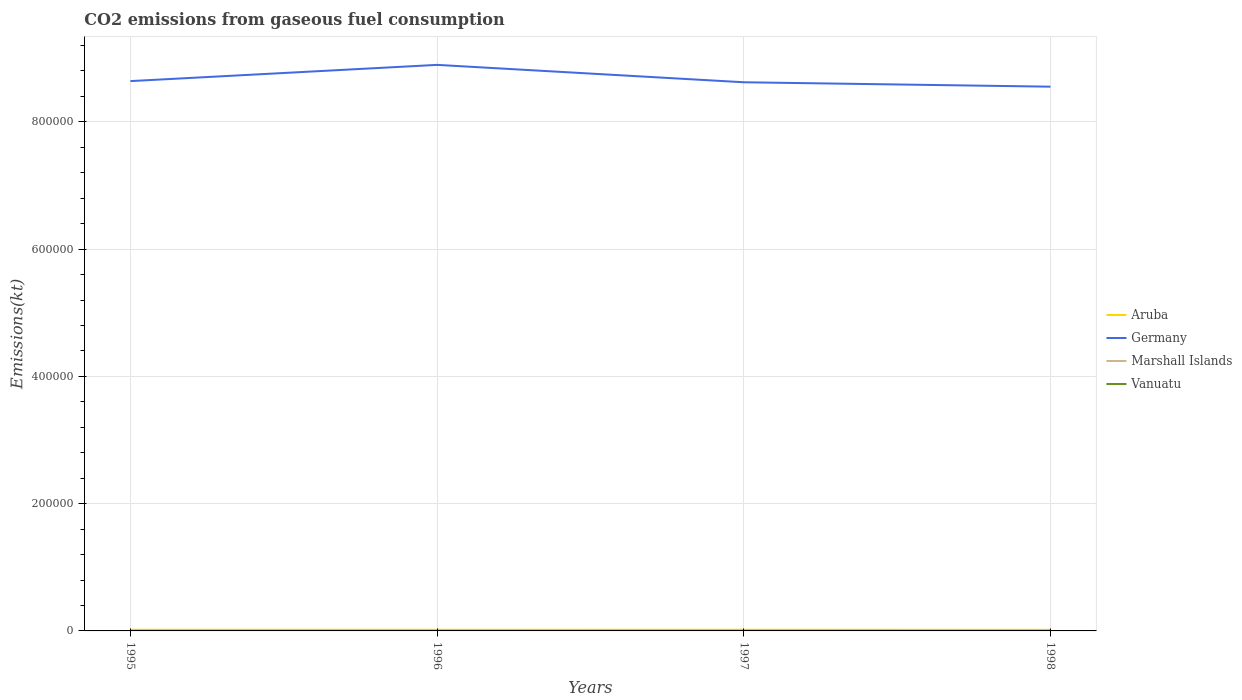Across all years, what is the maximum amount of CO2 emitted in Vanuatu?
Make the answer very short. 66.01. In which year was the amount of CO2 emitted in Marshall Islands maximum?
Your answer should be compact. 1995. What is the total amount of CO2 emitted in Aruba in the graph?
Your response must be concise. -36.67. What is the difference between the highest and the second highest amount of CO2 emitted in Aruba?
Offer a very short reply. 124.68. What is the difference between the highest and the lowest amount of CO2 emitted in Germany?
Your response must be concise. 1. Is the amount of CO2 emitted in Germany strictly greater than the amount of CO2 emitted in Vanuatu over the years?
Your answer should be compact. No. How many lines are there?
Ensure brevity in your answer.  4. Are the values on the major ticks of Y-axis written in scientific E-notation?
Your answer should be very brief. No. Does the graph contain any zero values?
Your response must be concise. No. Does the graph contain grids?
Provide a short and direct response. Yes. Where does the legend appear in the graph?
Offer a terse response. Center right. How many legend labels are there?
Ensure brevity in your answer.  4. How are the legend labels stacked?
Make the answer very short. Vertical. What is the title of the graph?
Keep it short and to the point. CO2 emissions from gaseous fuel consumption. Does "Rwanda" appear as one of the legend labels in the graph?
Give a very brief answer. No. What is the label or title of the Y-axis?
Make the answer very short. Emissions(kt). What is the Emissions(kt) in Aruba in 1995?
Ensure brevity in your answer.  1782.16. What is the Emissions(kt) in Germany in 1995?
Your response must be concise. 8.64e+05. What is the Emissions(kt) of Marshall Islands in 1995?
Provide a succinct answer. 66.01. What is the Emissions(kt) in Vanuatu in 1995?
Your answer should be compact. 66.01. What is the Emissions(kt) in Aruba in 1996?
Your answer should be compact. 1800.5. What is the Emissions(kt) in Germany in 1996?
Make the answer very short. 8.90e+05. What is the Emissions(kt) in Marshall Islands in 1996?
Your answer should be compact. 66.01. What is the Emissions(kt) in Vanuatu in 1996?
Provide a succinct answer. 84.34. What is the Emissions(kt) in Aruba in 1997?
Offer a terse response. 1837.17. What is the Emissions(kt) of Germany in 1997?
Offer a very short reply. 8.62e+05. What is the Emissions(kt) in Marshall Islands in 1997?
Provide a short and direct response. 66.01. What is the Emissions(kt) of Vanuatu in 1997?
Make the answer very short. 88.01. What is the Emissions(kt) of Aruba in 1998?
Give a very brief answer. 1712.49. What is the Emissions(kt) in Germany in 1998?
Your response must be concise. 8.55e+05. What is the Emissions(kt) of Marshall Islands in 1998?
Your answer should be compact. 69.67. What is the Emissions(kt) in Vanuatu in 1998?
Offer a very short reply. 84.34. Across all years, what is the maximum Emissions(kt) of Aruba?
Provide a short and direct response. 1837.17. Across all years, what is the maximum Emissions(kt) in Germany?
Make the answer very short. 8.90e+05. Across all years, what is the maximum Emissions(kt) in Marshall Islands?
Your answer should be very brief. 69.67. Across all years, what is the maximum Emissions(kt) of Vanuatu?
Keep it short and to the point. 88.01. Across all years, what is the minimum Emissions(kt) in Aruba?
Provide a short and direct response. 1712.49. Across all years, what is the minimum Emissions(kt) in Germany?
Your answer should be very brief. 8.55e+05. Across all years, what is the minimum Emissions(kt) in Marshall Islands?
Provide a short and direct response. 66.01. Across all years, what is the minimum Emissions(kt) in Vanuatu?
Your answer should be very brief. 66.01. What is the total Emissions(kt) in Aruba in the graph?
Give a very brief answer. 7132.31. What is the total Emissions(kt) in Germany in the graph?
Your response must be concise. 3.47e+06. What is the total Emissions(kt) in Marshall Islands in the graph?
Your answer should be very brief. 267.69. What is the total Emissions(kt) of Vanuatu in the graph?
Keep it short and to the point. 322.7. What is the difference between the Emissions(kt) in Aruba in 1995 and that in 1996?
Your answer should be very brief. -18.34. What is the difference between the Emissions(kt) of Germany in 1995 and that in 1996?
Provide a short and direct response. -2.55e+04. What is the difference between the Emissions(kt) of Marshall Islands in 1995 and that in 1996?
Your answer should be very brief. 0. What is the difference between the Emissions(kt) in Vanuatu in 1995 and that in 1996?
Your answer should be very brief. -18.34. What is the difference between the Emissions(kt) of Aruba in 1995 and that in 1997?
Offer a very short reply. -55.01. What is the difference between the Emissions(kt) of Germany in 1995 and that in 1997?
Ensure brevity in your answer.  1833.5. What is the difference between the Emissions(kt) in Marshall Islands in 1995 and that in 1997?
Provide a short and direct response. 0. What is the difference between the Emissions(kt) in Vanuatu in 1995 and that in 1997?
Your response must be concise. -22. What is the difference between the Emissions(kt) of Aruba in 1995 and that in 1998?
Give a very brief answer. 69.67. What is the difference between the Emissions(kt) of Germany in 1995 and that in 1998?
Make the answer very short. 8745.8. What is the difference between the Emissions(kt) of Marshall Islands in 1995 and that in 1998?
Provide a succinct answer. -3.67. What is the difference between the Emissions(kt) in Vanuatu in 1995 and that in 1998?
Give a very brief answer. -18.34. What is the difference between the Emissions(kt) of Aruba in 1996 and that in 1997?
Ensure brevity in your answer.  -36.67. What is the difference between the Emissions(kt) in Germany in 1996 and that in 1997?
Your answer should be very brief. 2.73e+04. What is the difference between the Emissions(kt) in Marshall Islands in 1996 and that in 1997?
Your response must be concise. 0. What is the difference between the Emissions(kt) of Vanuatu in 1996 and that in 1997?
Your response must be concise. -3.67. What is the difference between the Emissions(kt) of Aruba in 1996 and that in 1998?
Offer a terse response. 88.01. What is the difference between the Emissions(kt) in Germany in 1996 and that in 1998?
Keep it short and to the point. 3.42e+04. What is the difference between the Emissions(kt) of Marshall Islands in 1996 and that in 1998?
Keep it short and to the point. -3.67. What is the difference between the Emissions(kt) of Aruba in 1997 and that in 1998?
Provide a succinct answer. 124.68. What is the difference between the Emissions(kt) of Germany in 1997 and that in 1998?
Give a very brief answer. 6912.3. What is the difference between the Emissions(kt) of Marshall Islands in 1997 and that in 1998?
Ensure brevity in your answer.  -3.67. What is the difference between the Emissions(kt) in Vanuatu in 1997 and that in 1998?
Offer a terse response. 3.67. What is the difference between the Emissions(kt) in Aruba in 1995 and the Emissions(kt) in Germany in 1996?
Your answer should be compact. -8.88e+05. What is the difference between the Emissions(kt) of Aruba in 1995 and the Emissions(kt) of Marshall Islands in 1996?
Keep it short and to the point. 1716.16. What is the difference between the Emissions(kt) of Aruba in 1995 and the Emissions(kt) of Vanuatu in 1996?
Offer a very short reply. 1697.82. What is the difference between the Emissions(kt) in Germany in 1995 and the Emissions(kt) in Marshall Islands in 1996?
Make the answer very short. 8.64e+05. What is the difference between the Emissions(kt) of Germany in 1995 and the Emissions(kt) of Vanuatu in 1996?
Keep it short and to the point. 8.64e+05. What is the difference between the Emissions(kt) of Marshall Islands in 1995 and the Emissions(kt) of Vanuatu in 1996?
Offer a terse response. -18.34. What is the difference between the Emissions(kt) in Aruba in 1995 and the Emissions(kt) in Germany in 1997?
Offer a terse response. -8.60e+05. What is the difference between the Emissions(kt) in Aruba in 1995 and the Emissions(kt) in Marshall Islands in 1997?
Keep it short and to the point. 1716.16. What is the difference between the Emissions(kt) of Aruba in 1995 and the Emissions(kt) of Vanuatu in 1997?
Offer a terse response. 1694.15. What is the difference between the Emissions(kt) of Germany in 1995 and the Emissions(kt) of Marshall Islands in 1997?
Provide a short and direct response. 8.64e+05. What is the difference between the Emissions(kt) of Germany in 1995 and the Emissions(kt) of Vanuatu in 1997?
Your response must be concise. 8.64e+05. What is the difference between the Emissions(kt) of Marshall Islands in 1995 and the Emissions(kt) of Vanuatu in 1997?
Your answer should be very brief. -22. What is the difference between the Emissions(kt) of Aruba in 1995 and the Emissions(kt) of Germany in 1998?
Make the answer very short. -8.54e+05. What is the difference between the Emissions(kt) in Aruba in 1995 and the Emissions(kt) in Marshall Islands in 1998?
Provide a short and direct response. 1712.49. What is the difference between the Emissions(kt) in Aruba in 1995 and the Emissions(kt) in Vanuatu in 1998?
Provide a succinct answer. 1697.82. What is the difference between the Emissions(kt) of Germany in 1995 and the Emissions(kt) of Marshall Islands in 1998?
Give a very brief answer. 8.64e+05. What is the difference between the Emissions(kt) in Germany in 1995 and the Emissions(kt) in Vanuatu in 1998?
Give a very brief answer. 8.64e+05. What is the difference between the Emissions(kt) in Marshall Islands in 1995 and the Emissions(kt) in Vanuatu in 1998?
Provide a succinct answer. -18.34. What is the difference between the Emissions(kt) in Aruba in 1996 and the Emissions(kt) in Germany in 1997?
Give a very brief answer. -8.60e+05. What is the difference between the Emissions(kt) in Aruba in 1996 and the Emissions(kt) in Marshall Islands in 1997?
Your answer should be compact. 1734.49. What is the difference between the Emissions(kt) in Aruba in 1996 and the Emissions(kt) in Vanuatu in 1997?
Your answer should be compact. 1712.49. What is the difference between the Emissions(kt) of Germany in 1996 and the Emissions(kt) of Marshall Islands in 1997?
Your answer should be compact. 8.90e+05. What is the difference between the Emissions(kt) in Germany in 1996 and the Emissions(kt) in Vanuatu in 1997?
Ensure brevity in your answer.  8.90e+05. What is the difference between the Emissions(kt) of Marshall Islands in 1996 and the Emissions(kt) of Vanuatu in 1997?
Give a very brief answer. -22. What is the difference between the Emissions(kt) of Aruba in 1996 and the Emissions(kt) of Germany in 1998?
Provide a succinct answer. -8.54e+05. What is the difference between the Emissions(kt) in Aruba in 1996 and the Emissions(kt) in Marshall Islands in 1998?
Offer a very short reply. 1730.82. What is the difference between the Emissions(kt) of Aruba in 1996 and the Emissions(kt) of Vanuatu in 1998?
Make the answer very short. 1716.16. What is the difference between the Emissions(kt) in Germany in 1996 and the Emissions(kt) in Marshall Islands in 1998?
Your answer should be compact. 8.90e+05. What is the difference between the Emissions(kt) of Germany in 1996 and the Emissions(kt) of Vanuatu in 1998?
Your answer should be compact. 8.90e+05. What is the difference between the Emissions(kt) in Marshall Islands in 1996 and the Emissions(kt) in Vanuatu in 1998?
Give a very brief answer. -18.34. What is the difference between the Emissions(kt) of Aruba in 1997 and the Emissions(kt) of Germany in 1998?
Ensure brevity in your answer.  -8.54e+05. What is the difference between the Emissions(kt) in Aruba in 1997 and the Emissions(kt) in Marshall Islands in 1998?
Your answer should be compact. 1767.49. What is the difference between the Emissions(kt) of Aruba in 1997 and the Emissions(kt) of Vanuatu in 1998?
Keep it short and to the point. 1752.83. What is the difference between the Emissions(kt) of Germany in 1997 and the Emissions(kt) of Marshall Islands in 1998?
Offer a terse response. 8.62e+05. What is the difference between the Emissions(kt) in Germany in 1997 and the Emissions(kt) in Vanuatu in 1998?
Make the answer very short. 8.62e+05. What is the difference between the Emissions(kt) in Marshall Islands in 1997 and the Emissions(kt) in Vanuatu in 1998?
Your answer should be compact. -18.34. What is the average Emissions(kt) in Aruba per year?
Provide a short and direct response. 1783.08. What is the average Emissions(kt) in Germany per year?
Ensure brevity in your answer.  8.68e+05. What is the average Emissions(kt) of Marshall Islands per year?
Keep it short and to the point. 66.92. What is the average Emissions(kt) in Vanuatu per year?
Provide a short and direct response. 80.67. In the year 1995, what is the difference between the Emissions(kt) in Aruba and Emissions(kt) in Germany?
Give a very brief answer. -8.62e+05. In the year 1995, what is the difference between the Emissions(kt) in Aruba and Emissions(kt) in Marshall Islands?
Offer a very short reply. 1716.16. In the year 1995, what is the difference between the Emissions(kt) of Aruba and Emissions(kt) of Vanuatu?
Make the answer very short. 1716.16. In the year 1995, what is the difference between the Emissions(kt) in Germany and Emissions(kt) in Marshall Islands?
Make the answer very short. 8.64e+05. In the year 1995, what is the difference between the Emissions(kt) in Germany and Emissions(kt) in Vanuatu?
Ensure brevity in your answer.  8.64e+05. In the year 1995, what is the difference between the Emissions(kt) in Marshall Islands and Emissions(kt) in Vanuatu?
Ensure brevity in your answer.  0. In the year 1996, what is the difference between the Emissions(kt) of Aruba and Emissions(kt) of Germany?
Make the answer very short. -8.88e+05. In the year 1996, what is the difference between the Emissions(kt) of Aruba and Emissions(kt) of Marshall Islands?
Give a very brief answer. 1734.49. In the year 1996, what is the difference between the Emissions(kt) in Aruba and Emissions(kt) in Vanuatu?
Ensure brevity in your answer.  1716.16. In the year 1996, what is the difference between the Emissions(kt) of Germany and Emissions(kt) of Marshall Islands?
Your response must be concise. 8.90e+05. In the year 1996, what is the difference between the Emissions(kt) in Germany and Emissions(kt) in Vanuatu?
Provide a short and direct response. 8.90e+05. In the year 1996, what is the difference between the Emissions(kt) of Marshall Islands and Emissions(kt) of Vanuatu?
Offer a very short reply. -18.34. In the year 1997, what is the difference between the Emissions(kt) of Aruba and Emissions(kt) of Germany?
Provide a succinct answer. -8.60e+05. In the year 1997, what is the difference between the Emissions(kt) of Aruba and Emissions(kt) of Marshall Islands?
Your answer should be compact. 1771.16. In the year 1997, what is the difference between the Emissions(kt) in Aruba and Emissions(kt) in Vanuatu?
Your answer should be very brief. 1749.16. In the year 1997, what is the difference between the Emissions(kt) of Germany and Emissions(kt) of Marshall Islands?
Keep it short and to the point. 8.62e+05. In the year 1997, what is the difference between the Emissions(kt) of Germany and Emissions(kt) of Vanuatu?
Your answer should be compact. 8.62e+05. In the year 1997, what is the difference between the Emissions(kt) of Marshall Islands and Emissions(kt) of Vanuatu?
Offer a terse response. -22. In the year 1998, what is the difference between the Emissions(kt) in Aruba and Emissions(kt) in Germany?
Offer a very short reply. -8.54e+05. In the year 1998, what is the difference between the Emissions(kt) in Aruba and Emissions(kt) in Marshall Islands?
Provide a succinct answer. 1642.82. In the year 1998, what is the difference between the Emissions(kt) of Aruba and Emissions(kt) of Vanuatu?
Your answer should be compact. 1628.15. In the year 1998, what is the difference between the Emissions(kt) of Germany and Emissions(kt) of Marshall Islands?
Give a very brief answer. 8.55e+05. In the year 1998, what is the difference between the Emissions(kt) in Germany and Emissions(kt) in Vanuatu?
Your answer should be very brief. 8.55e+05. In the year 1998, what is the difference between the Emissions(kt) in Marshall Islands and Emissions(kt) in Vanuatu?
Ensure brevity in your answer.  -14.67. What is the ratio of the Emissions(kt) in Aruba in 1995 to that in 1996?
Provide a succinct answer. 0.99. What is the ratio of the Emissions(kt) of Germany in 1995 to that in 1996?
Your response must be concise. 0.97. What is the ratio of the Emissions(kt) in Vanuatu in 1995 to that in 1996?
Keep it short and to the point. 0.78. What is the ratio of the Emissions(kt) of Aruba in 1995 to that in 1997?
Your answer should be compact. 0.97. What is the ratio of the Emissions(kt) of Aruba in 1995 to that in 1998?
Ensure brevity in your answer.  1.04. What is the ratio of the Emissions(kt) in Germany in 1995 to that in 1998?
Keep it short and to the point. 1.01. What is the ratio of the Emissions(kt) of Marshall Islands in 1995 to that in 1998?
Make the answer very short. 0.95. What is the ratio of the Emissions(kt) in Vanuatu in 1995 to that in 1998?
Offer a terse response. 0.78. What is the ratio of the Emissions(kt) in Germany in 1996 to that in 1997?
Your answer should be very brief. 1.03. What is the ratio of the Emissions(kt) of Marshall Islands in 1996 to that in 1997?
Give a very brief answer. 1. What is the ratio of the Emissions(kt) of Aruba in 1996 to that in 1998?
Ensure brevity in your answer.  1.05. What is the ratio of the Emissions(kt) in Marshall Islands in 1996 to that in 1998?
Make the answer very short. 0.95. What is the ratio of the Emissions(kt) of Vanuatu in 1996 to that in 1998?
Provide a succinct answer. 1. What is the ratio of the Emissions(kt) in Aruba in 1997 to that in 1998?
Your answer should be compact. 1.07. What is the ratio of the Emissions(kt) in Germany in 1997 to that in 1998?
Give a very brief answer. 1.01. What is the ratio of the Emissions(kt) in Marshall Islands in 1997 to that in 1998?
Make the answer very short. 0.95. What is the ratio of the Emissions(kt) of Vanuatu in 1997 to that in 1998?
Your answer should be very brief. 1.04. What is the difference between the highest and the second highest Emissions(kt) in Aruba?
Offer a terse response. 36.67. What is the difference between the highest and the second highest Emissions(kt) in Germany?
Your answer should be very brief. 2.55e+04. What is the difference between the highest and the second highest Emissions(kt) of Marshall Islands?
Your answer should be very brief. 3.67. What is the difference between the highest and the second highest Emissions(kt) in Vanuatu?
Keep it short and to the point. 3.67. What is the difference between the highest and the lowest Emissions(kt) of Aruba?
Ensure brevity in your answer.  124.68. What is the difference between the highest and the lowest Emissions(kt) in Germany?
Ensure brevity in your answer.  3.42e+04. What is the difference between the highest and the lowest Emissions(kt) of Marshall Islands?
Your answer should be compact. 3.67. What is the difference between the highest and the lowest Emissions(kt) in Vanuatu?
Make the answer very short. 22. 